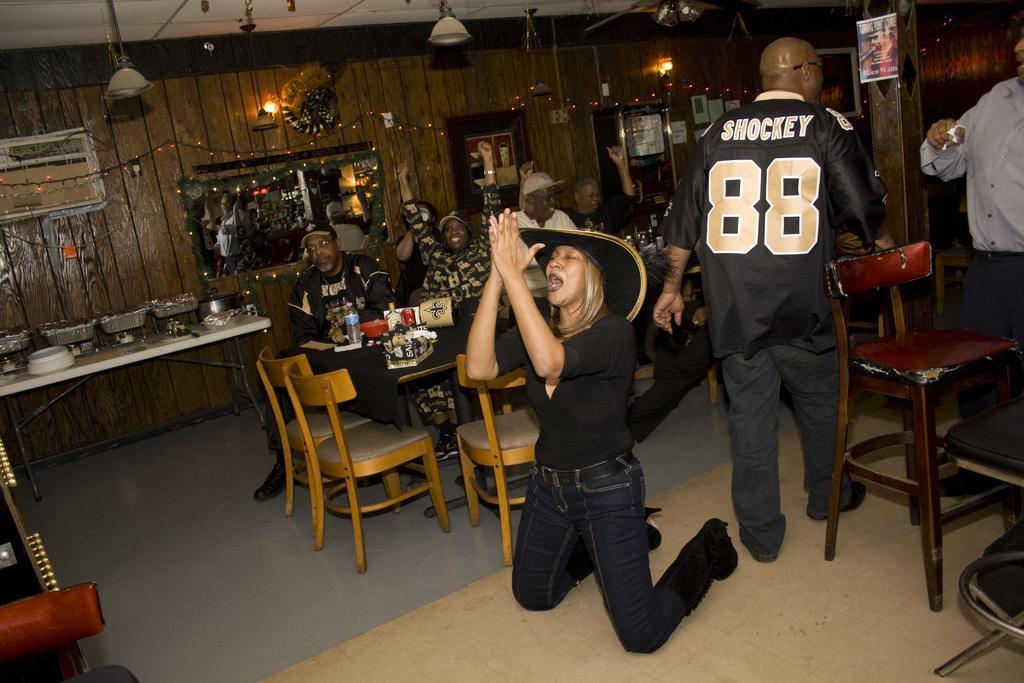Could you give a brief overview of what you see in this image? In this image the woman is kneeling down on the floor and clapping. In the middle there is a table and there are people who are sitting around the table. At the background people are enjoying by drinking. At the background there is a wall,window,light,trays,table. 